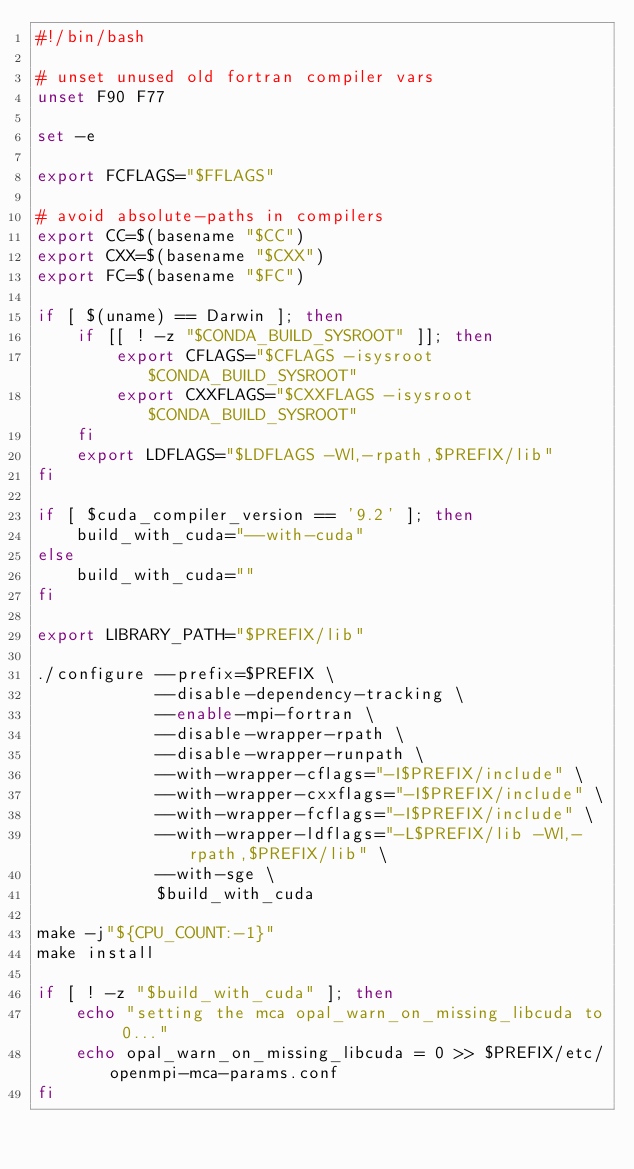Convert code to text. <code><loc_0><loc_0><loc_500><loc_500><_Bash_>#!/bin/bash

# unset unused old fortran compiler vars
unset F90 F77

set -e

export FCFLAGS="$FFLAGS"

# avoid absolute-paths in compilers
export CC=$(basename "$CC")
export CXX=$(basename "$CXX")
export FC=$(basename "$FC")

if [ $(uname) == Darwin ]; then
    if [[ ! -z "$CONDA_BUILD_SYSROOT" ]]; then
        export CFLAGS="$CFLAGS -isysroot $CONDA_BUILD_SYSROOT"
        export CXXFLAGS="$CXXFLAGS -isysroot $CONDA_BUILD_SYSROOT"
    fi
    export LDFLAGS="$LDFLAGS -Wl,-rpath,$PREFIX/lib"
fi

if [ $cuda_compiler_version == '9.2' ]; then
    build_with_cuda="--with-cuda"
else
    build_with_cuda=""
fi

export LIBRARY_PATH="$PREFIX/lib"

./configure --prefix=$PREFIX \
            --disable-dependency-tracking \
            --enable-mpi-fortran \
            --disable-wrapper-rpath \
            --disable-wrapper-runpath \
            --with-wrapper-cflags="-I$PREFIX/include" \
            --with-wrapper-cxxflags="-I$PREFIX/include" \
            --with-wrapper-fcflags="-I$PREFIX/include" \
            --with-wrapper-ldflags="-L$PREFIX/lib -Wl,-rpath,$PREFIX/lib" \
            --with-sge \
            $build_with_cuda

make -j"${CPU_COUNT:-1}"
make install

if [ ! -z "$build_with_cuda" ]; then
    echo "setting the mca opal_warn_on_missing_libcuda to 0..."
    echo opal_warn_on_missing_libcuda = 0 >> $PREFIX/etc/openmpi-mca-params.conf
fi
</code> 